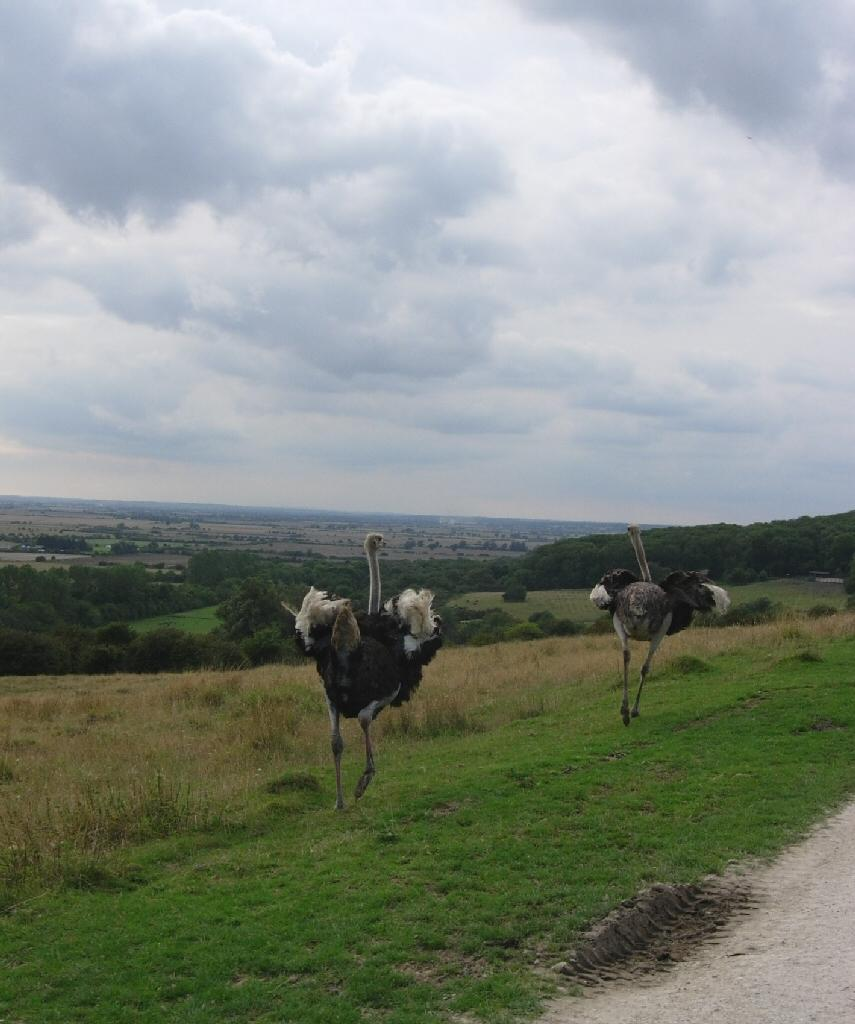How many birds can be seen in the image? There are two birds in the image. What are the birds doing in the image? The birds are walking. What can be seen in the background of the image? There are trees and a cloudy sky in the background of the image. What type of gold object is being carried by the laborer in the image? There is no laborer or gold object present in the image; it features two birds walking and a background with trees and a cloudy sky. 